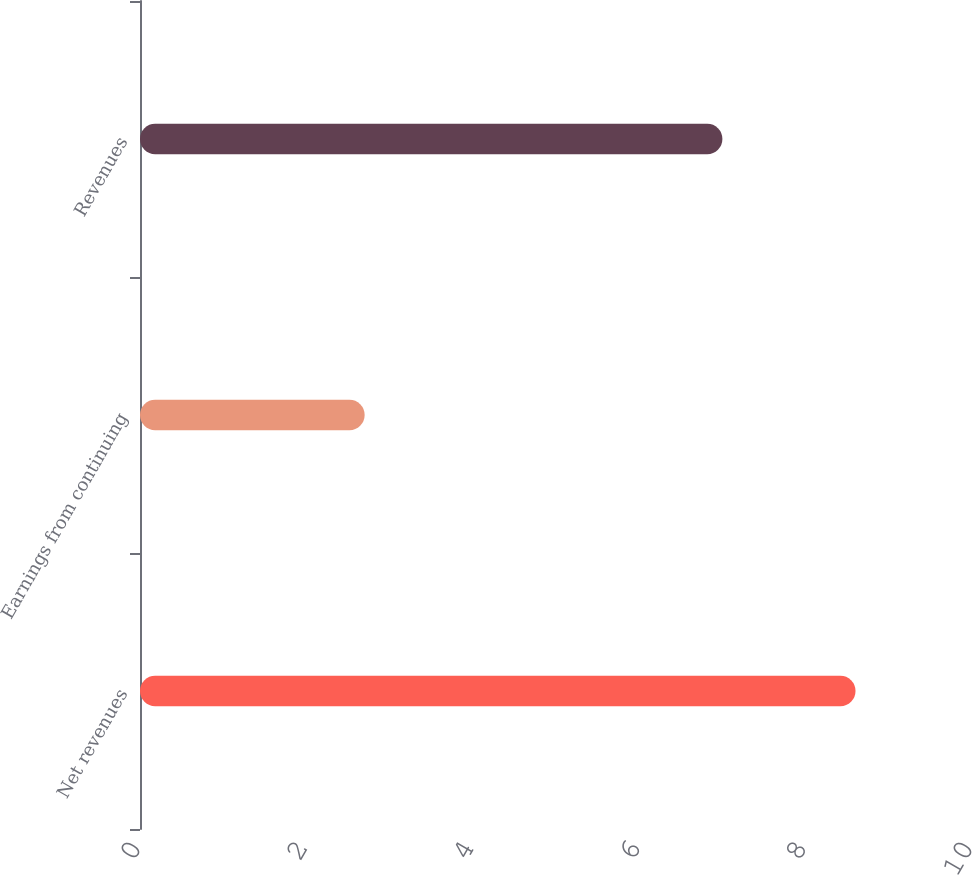Convert chart to OTSL. <chart><loc_0><loc_0><loc_500><loc_500><bar_chart><fcel>Net revenues<fcel>Earnings from continuing<fcel>Revenues<nl><fcel>8.6<fcel>2.7<fcel>7<nl></chart> 